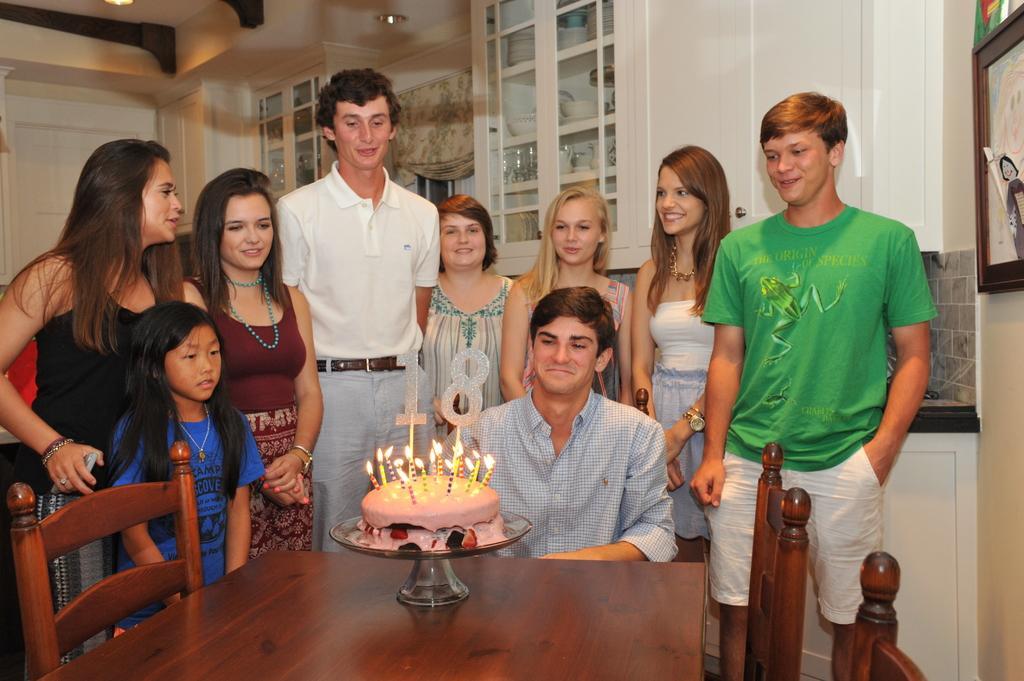Could you give a brief overview of what you see in this image? In this picture we can see some persons standing on the floor. Here we can see a man who is sitting on the chair. This is table. On the table there is a cake. And these are candles. On the background we can see cupboards. This is light. 